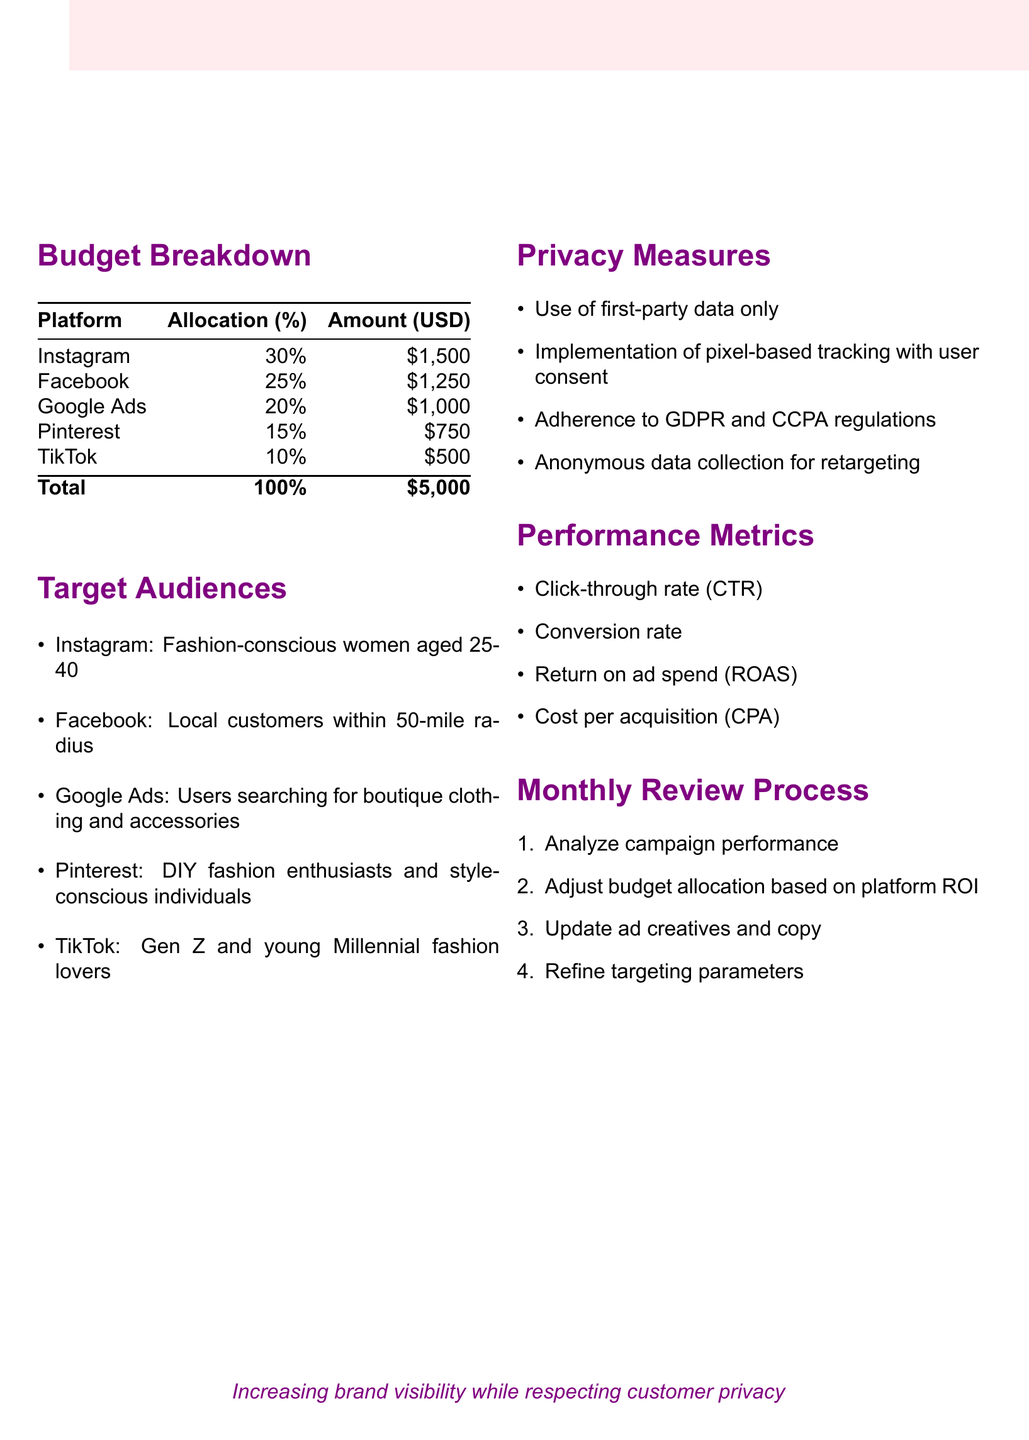What is the budget allocation for Instagram? The budget allocation for Instagram is shown in the budget breakdown table document as 30%.
Answer: 30% What is the total advertising budget? The total advertising budget appears at the end of the budget breakdown, which sums up to $5,000.
Answer: $5,000 What percentage of the budget is allocated to TikTok? The document specifies that TikTok receives 10% of the total budget allocation.
Answer: 10% Who is the target audience for Google Ads? The document lists the target audience for Google Ads as users searching for boutique clothing and accessories.
Answer: Users searching for boutique clothing and accessories How many performance metrics are mentioned? The document lists four performance metrics, indicating the number mentioned.
Answer: 4 What privacy measure involves user consent? The document mentions the implementation of pixel-based tracking with user consent as a privacy measure.
Answer: Pixel-based tracking with user consent Which platform has the highest budget allocation? The budget breakdown indicates that Instagram has the highest allocation, compared to other platforms listed.
Answer: Instagram What is the purpose of the monthly review process? The monthly review process aims to analyze campaign performance and adjust various marketing strategies accordingly.
Answer: Analyze campaign performance What is the return on ad spend abbreviated as? The abbreviation for return on ad spend is given in the performance metrics section.
Answer: ROAS 